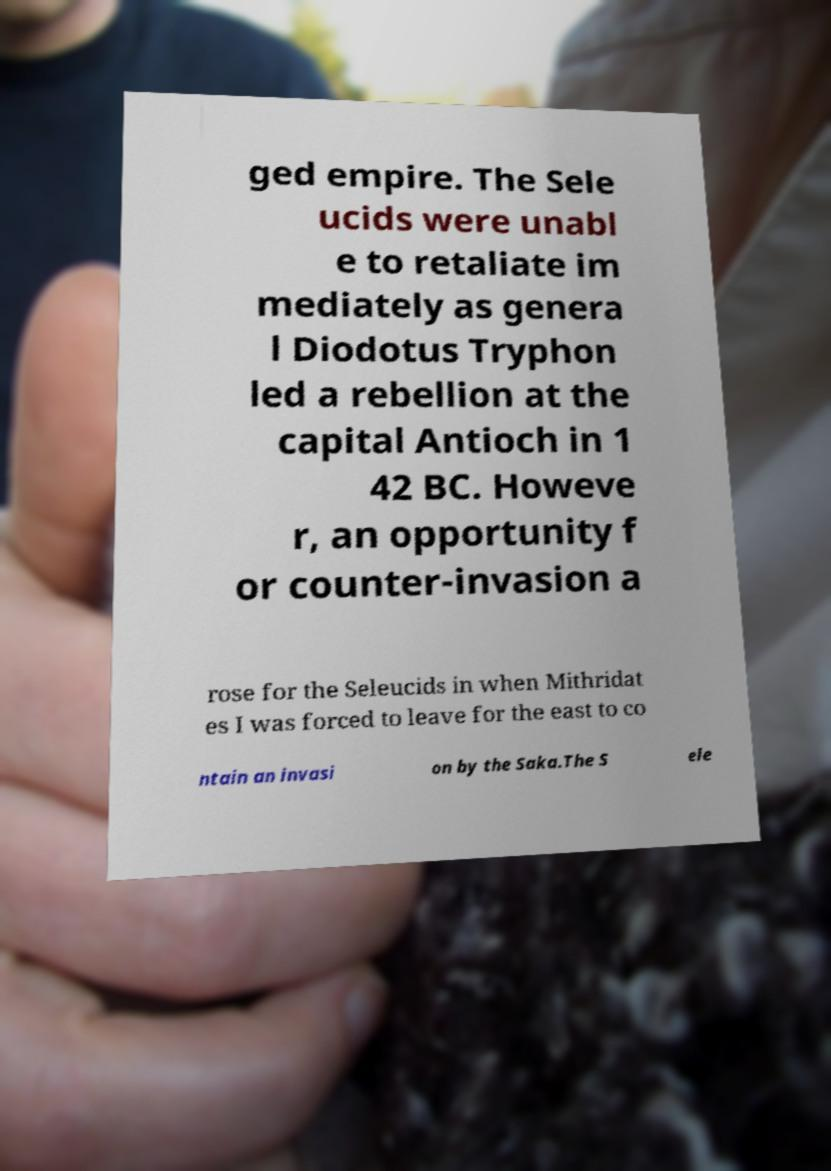Can you read and provide the text displayed in the image?This photo seems to have some interesting text. Can you extract and type it out for me? ged empire. The Sele ucids were unabl e to retaliate im mediately as genera l Diodotus Tryphon led a rebellion at the capital Antioch in 1 42 BC. Howeve r, an opportunity f or counter-invasion a rose for the Seleucids in when Mithridat es I was forced to leave for the east to co ntain an invasi on by the Saka.The S ele 